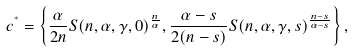<formula> <loc_0><loc_0><loc_500><loc_500>c ^ { ^ { * } } = \left \{ \frac { \alpha } { 2 n } S ( n , \alpha , \gamma , 0 ) ^ { \frac { n } { \alpha } } , \frac { \alpha - s } { 2 ( n - s ) } S ( n , \alpha , \gamma , s ) ^ { \frac { n - s } { \alpha - s } } \right \} ,</formula> 